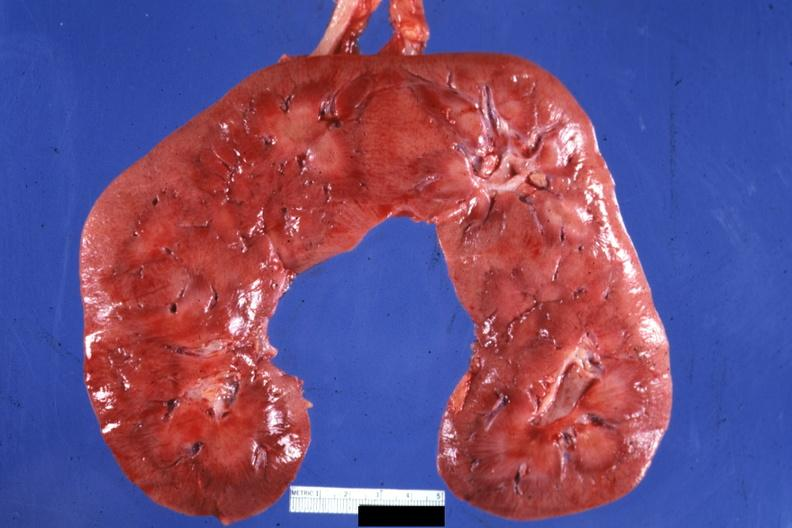where is this?
Answer the question using a single word or phrase. Urinary 